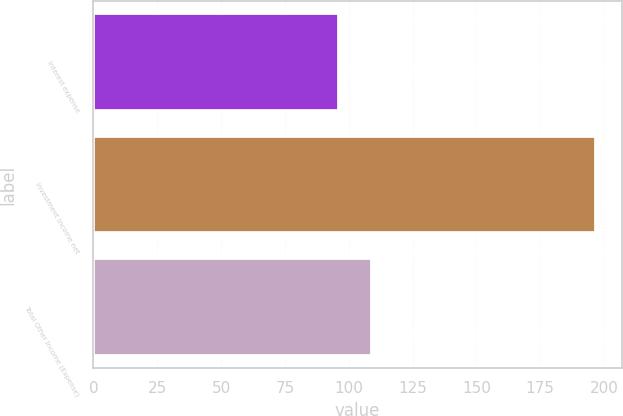Convert chart to OTSL. <chart><loc_0><loc_0><loc_500><loc_500><bar_chart><fcel>Interest expense<fcel>Investment income net<fcel>Total Other Income (Expense)<nl><fcel>96<fcel>197<fcel>109<nl></chart> 